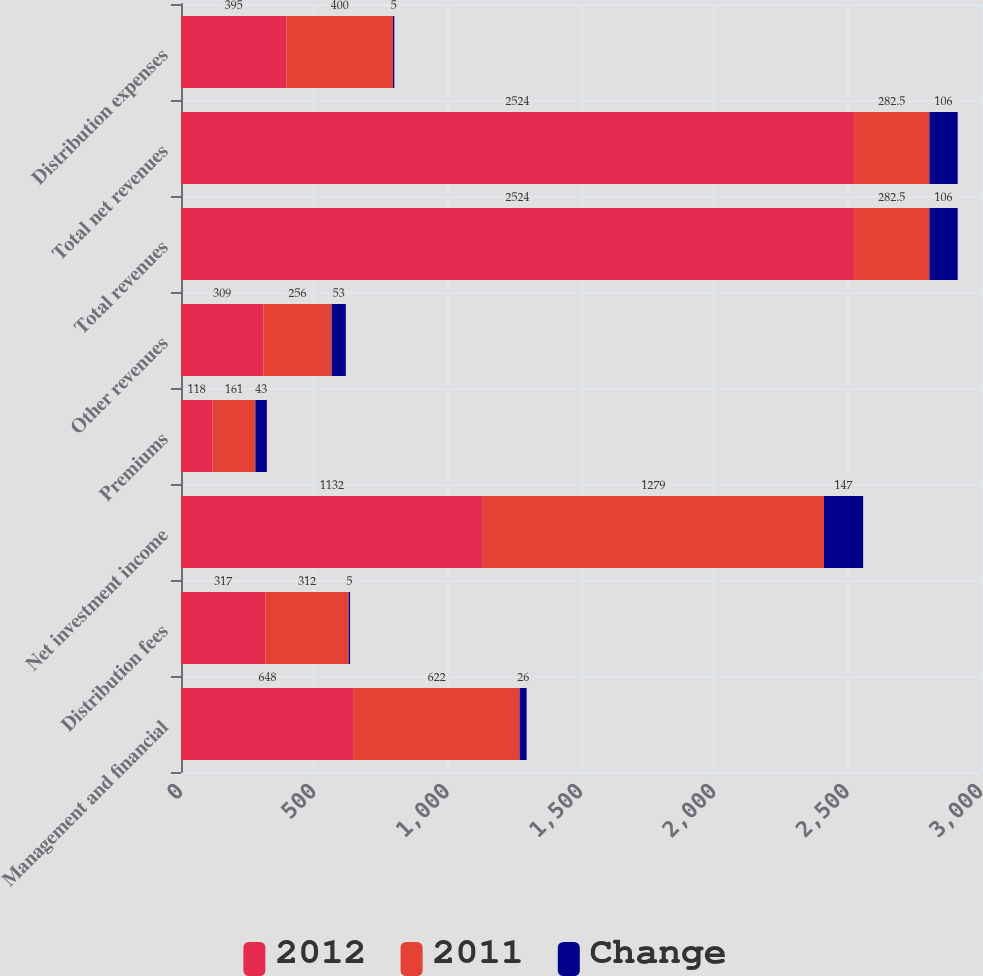Convert chart to OTSL. <chart><loc_0><loc_0><loc_500><loc_500><stacked_bar_chart><ecel><fcel>Management and financial<fcel>Distribution fees<fcel>Net investment income<fcel>Premiums<fcel>Other revenues<fcel>Total revenues<fcel>Total net revenues<fcel>Distribution expenses<nl><fcel>2012<fcel>648<fcel>317<fcel>1132<fcel>118<fcel>309<fcel>2524<fcel>2524<fcel>395<nl><fcel>2011<fcel>622<fcel>312<fcel>1279<fcel>161<fcel>256<fcel>282.5<fcel>282.5<fcel>400<nl><fcel>Change<fcel>26<fcel>5<fcel>147<fcel>43<fcel>53<fcel>106<fcel>106<fcel>5<nl></chart> 